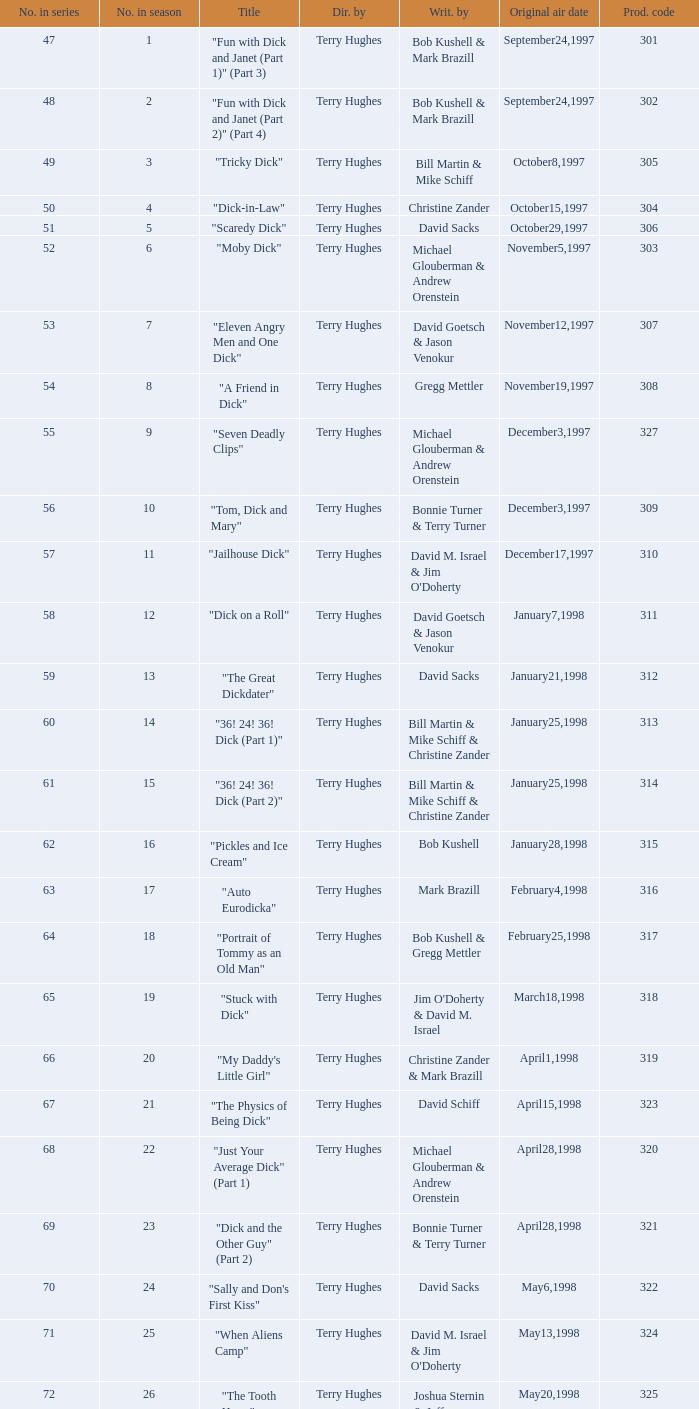Who were the writers of the episode titled "Tricky Dick"? Bill Martin & Mike Schiff. 